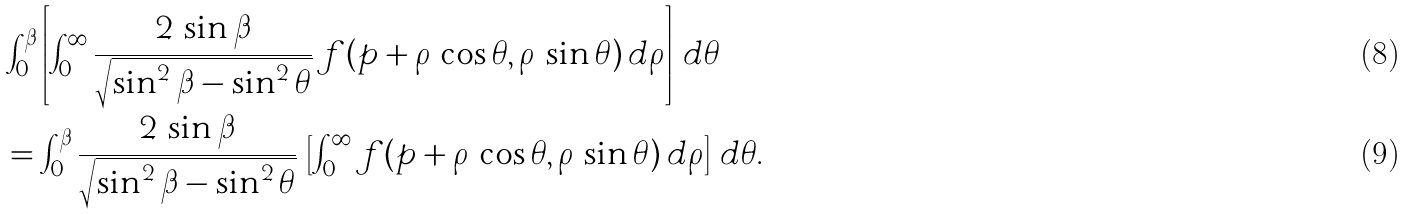Convert formula to latex. <formula><loc_0><loc_0><loc_500><loc_500>& \int _ { 0 } ^ { \beta } \left [ \int _ { 0 } ^ { \infty } \frac { 2 \, \sin \beta } { \sqrt { \sin ^ { 2 } \beta - \sin ^ { 2 } \theta } } \, f ( p + \rho \, \cos \theta , \rho \, \sin \theta ) \, d \rho \right ] \, d \theta \\ & = \int _ { 0 } ^ { \beta } \frac { 2 \, \sin \beta } { \sqrt { \sin ^ { 2 } \beta - \sin ^ { 2 } \theta } } \, \left [ \int _ { 0 } ^ { \infty } f ( p + \rho \, \cos \theta , \rho \, \sin \theta ) \, d \rho \right ] \, d \theta .</formula> 